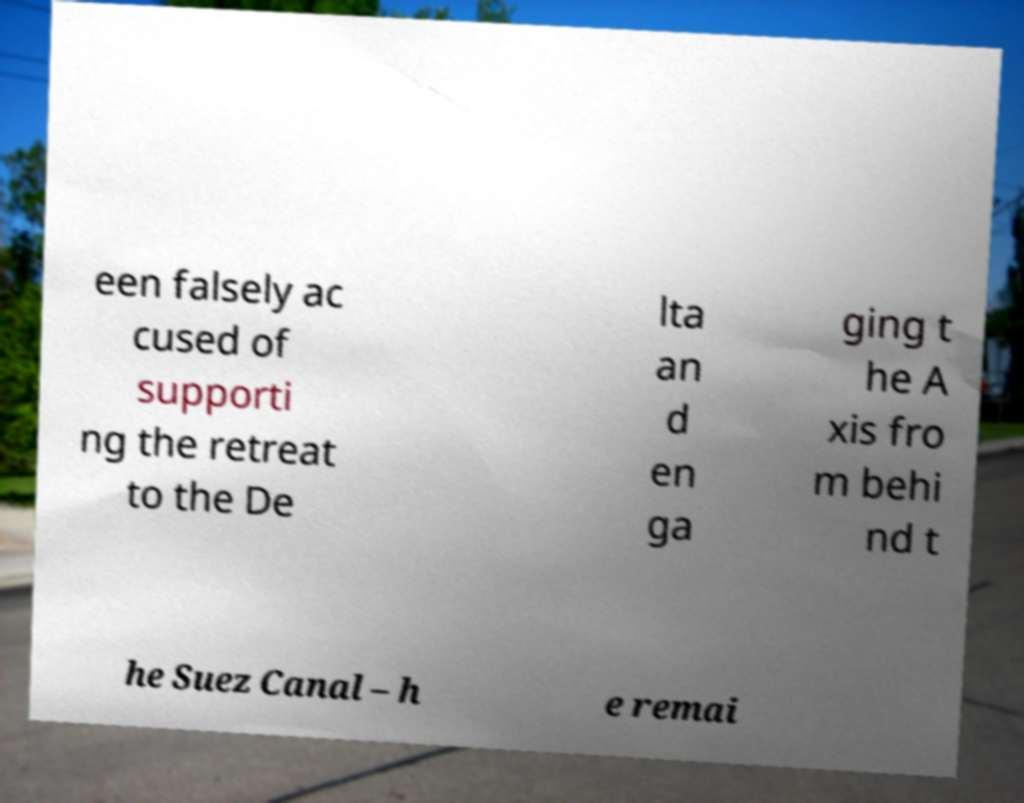Could you extract and type out the text from this image? een falsely ac cused of supporti ng the retreat to the De lta an d en ga ging t he A xis fro m behi nd t he Suez Canal – h e remai 